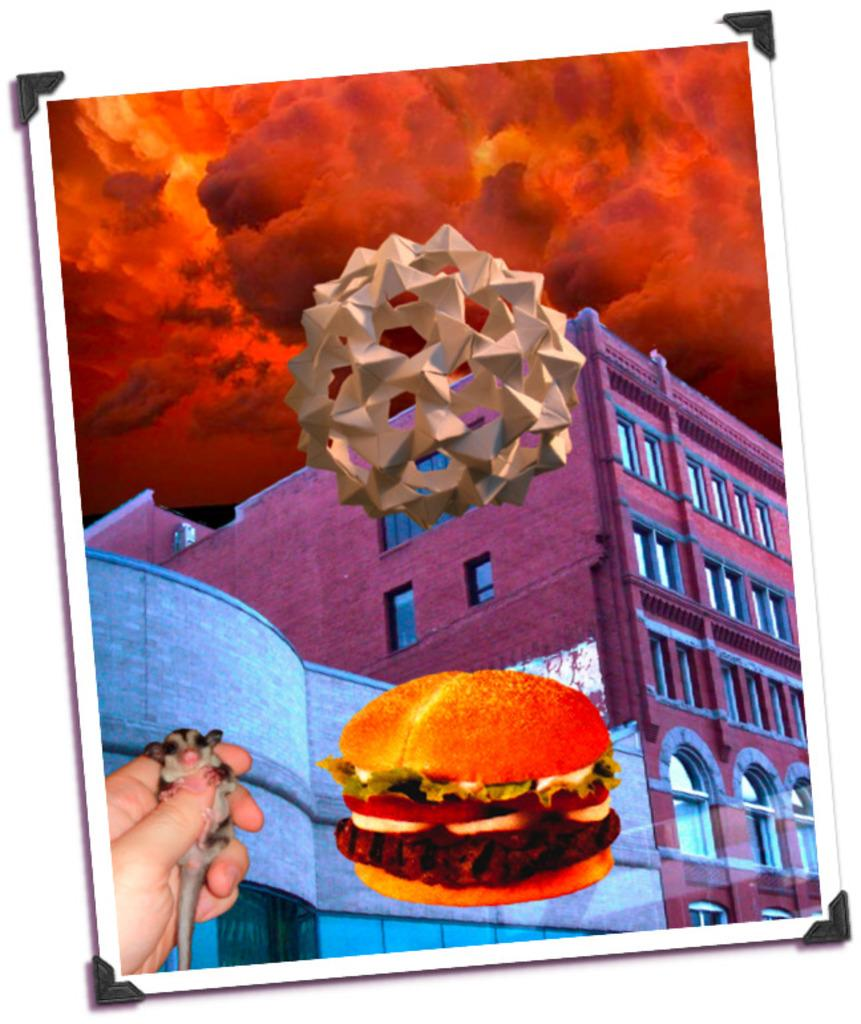What is the main subject of the image? There is a photograph in the image. What types of images are included in the photograph? The photograph contains pictures of fire, a building, a sculpture, a burger, and a person holding a rat. Can you describe the content of the photograph in more detail? The photograph includes images of fire, a building, a sculpture, a burger, and a person holding a rat. How many sisters are visible in the image? There are no sisters present in the image; it contains a photograph with various images, including fire, a building, a sculpture, a burger, and a person holding a rat. 